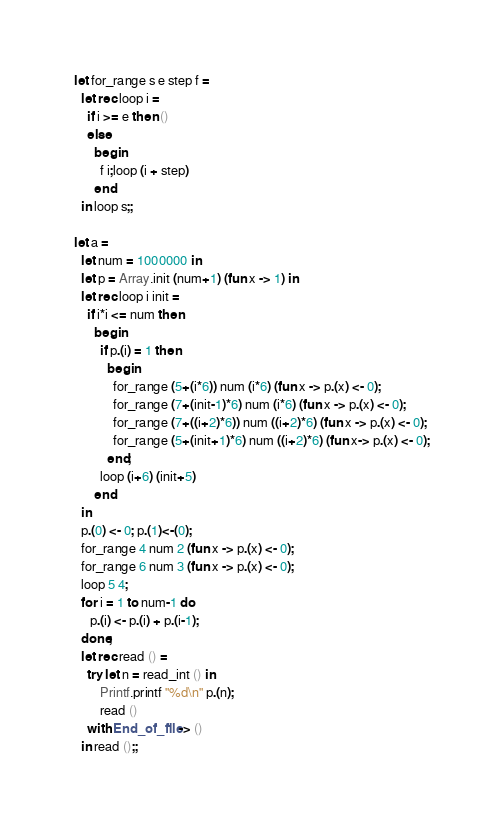<code> <loc_0><loc_0><loc_500><loc_500><_OCaml_>let for_range s e step f =
  let rec loop i =
    if i >= e then ()
    else
      begin
        f i;loop (i + step)
      end
  in loop s;;

let a =
  let num = 1000000 in
  let p = Array.init (num+1) (fun x -> 1) in
  let rec loop i init =
    if i*i <= num then
      begin
        if p.(i) = 1 then
          begin
            for_range (5+(i*6)) num (i*6) (fun x -> p.(x) <- 0);
            for_range (7+(init-1)*6) num (i*6) (fun x -> p.(x) <- 0);
            for_range (7+((i+2)*6)) num ((i+2)*6) (fun x -> p.(x) <- 0);
            for_range (5+(init+1)*6) num ((i+2)*6) (fun x-> p.(x) <- 0);
          end;
        loop (i+6) (init+5)
      end
  in
  p.(0) <- 0; p.(1)<-(0);
  for_range 4 num 2 (fun x -> p.(x) <- 0);
  for_range 6 num 3 (fun x -> p.(x) <- 0);
  loop 5 4;
  for i = 1 to num-1 do
     p.(i) <- p.(i) + p.(i-1);
  done;
  let rec read () =
    try let n = read_int () in
        Printf.printf "%d\n" p.(n);
        read ()
    with End_of_file -> ()
  in read ();;</code> 